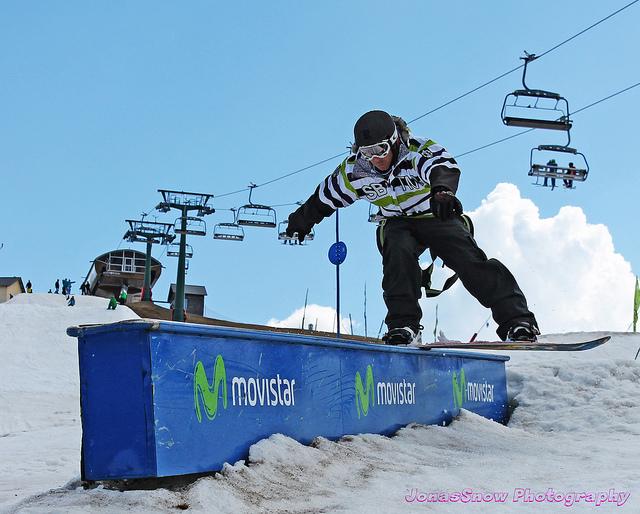Is it cold out there?
Write a very short answer. Yes. What is behind the person?
Short answer required. Ski lift. What is the color of the cloud?
Concise answer only. White. 